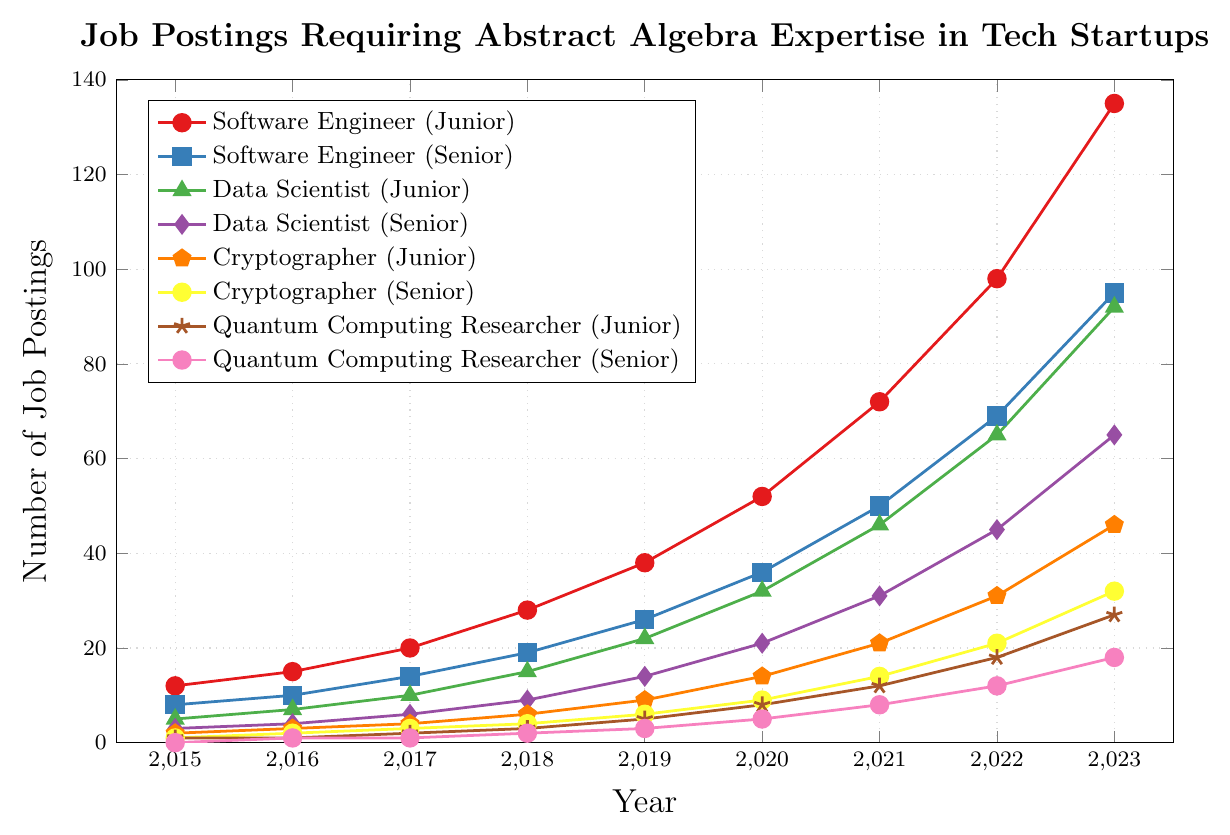What role has had the highest number of job postings in 2023? By examining the figure, in 2023, the "Software Engineer (Junior)" line reaches the highest on the y-axis, indicating the most postings.
Answer: Software Engineer (Junior) How many more job postings were there for "Data Scientist (Senior)" compared to "Cryptographer (Senior)" in 2021? According to the figure, in 2021, "Data Scientist (Senior)" had 31 postings, and "Cryptographer (Senior)" had 14. The difference is 31 - 14.
Answer: 17 Which role showed the greatest increase in job postings from 2015 to 2023? By comparing the lines between 2015 and 2023, "Software Engineer (Junior)" increased from 12 to 135, the largest increase among all roles.
Answer: Software Engineer (Junior) What is the average number of job postings for "Quantum Computing Researcher (Junior)" from 2019 to 2023? The values are 5, 8, 12, 18, and 27. The sum is 70, and there are 5 years, so the average is 70 / 5.
Answer: 14 In which year did "Cryptographer (Junior)" surpass double the number of "Cryptographer (Senior)" postings for the first time? For the line "Cryptographer (Junior)" to be double "Cryptographer (Senior)", find the earliest year where it surpasses twice the other. In 2019, "Cryptographer (Junior)" had 9 postings and "Cryptographer (Senior)" had 6 (less than half); this first happens in 2018 with 6 to 4.
Answer: 2018 How many total job postings were there across all senior "Data Scientist" roles in 2020? Sum the postings for "Data Scientist (Senior)" and "Data Scientist (Junior)" in 2020: 21 + 32.
Answer: 53 Which role’s job postings line is represented with a triangle marker? By checking the legend, the line with a triangle marker corresponds to "Data Scientist (Junior)".
Answer: Data Scientist (Junior) Which year shows the highest growth rate in job postings for "Software Engineer (Senior)"? The greatest increase in one year is the highest growth rate. The difference between 2022 (69) and 2023 (95) is 26, the highest yearly increase.
Answer: 2023 What is the median number of job postings for "Quantum Computing Researcher (Senior)" from 2016 to 2023? The values from 2016 to 2023 are 1, 1, 2, 3, 5, 8, 12, 18. The median is the average of the 4th and 5th values: (2 + 3)/2 = 2.5.
Answer: 2.5 Which role had consistent but lower growth in job postings compared to others, based on the visual slope of lines? Based on the consistently lower, less steep lines, "Quantum Computing Researcher (Senior)" has slower growth compared to others.
Answer: Quantum Computing Researcher (Senior) 